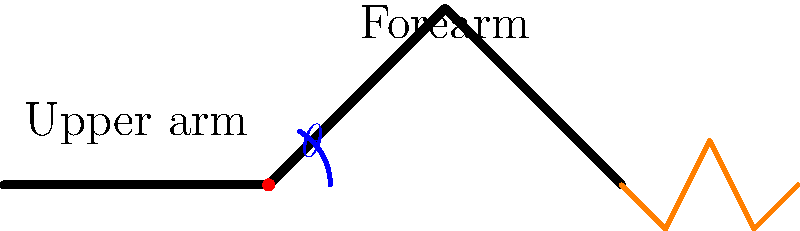As a competitive saxophonist striving for optimal performance, what is the ideal angle $\theta$ of elbow flexion when playing the saxophone, as shown in the diagram? To determine the optimal angle of elbow flexion for saxophone playing, we need to consider several factors:

1. Comfort and endurance: The angle should allow for prolonged playing without causing undue strain.

2. Instrument control: The angle must provide optimal control over the saxophone's keys and mouthpiece.

3. Sound production: The correct angle contributes to proper embouchure and air support.

4. Biomechanical efficiency: The angle should minimize unnecessary muscle tension and maximize energy transfer.

Research in music ergonomics and biomechanics suggests that:

a) An overly acute angle (< 80°) can cause tension in the forearm and restrict finger movement.
b) An excessively obtuse angle (> 120°) may lead to shoulder strain and reduced control.
c) The optimal range for elbow flexion during saxophone playing is generally between 90° and 110°.

Within this range, most professional saxophonists find that an angle of approximately 100° provides the best balance of comfort, control, and sound production efficiency.

This angle allows for:
- Relaxed forearm muscles
- Efficient finger movement across the keys
- Proper alignment of the wrist and hand
- Adequate support for the instrument's weight

It's important to note that slight variations may occur depending on individual physiology and playing style. However, maintaining an elbow flexion angle close to 100° is generally considered optimal for competitive saxophone performance.
Answer: Approximately 100° 